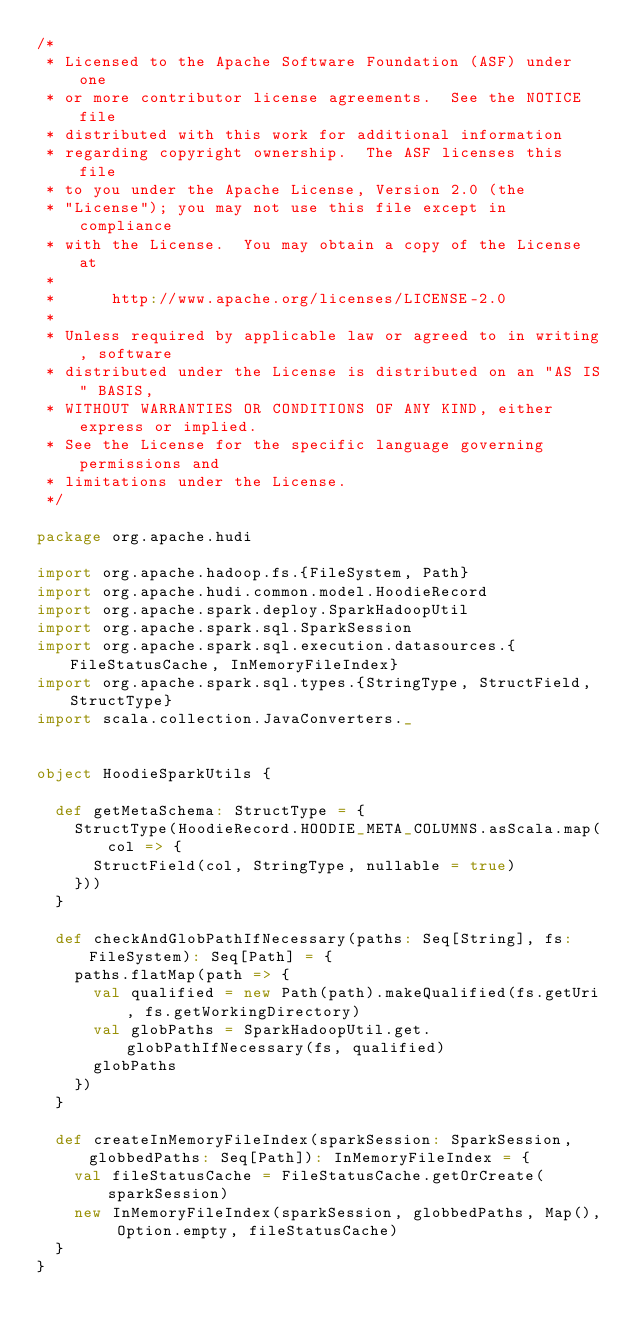Convert code to text. <code><loc_0><loc_0><loc_500><loc_500><_Scala_>/*
 * Licensed to the Apache Software Foundation (ASF) under one
 * or more contributor license agreements.  See the NOTICE file
 * distributed with this work for additional information
 * regarding copyright ownership.  The ASF licenses this file
 * to you under the Apache License, Version 2.0 (the
 * "License"); you may not use this file except in compliance
 * with the License.  You may obtain a copy of the License at
 *
 *      http://www.apache.org/licenses/LICENSE-2.0
 *
 * Unless required by applicable law or agreed to in writing, software
 * distributed under the License is distributed on an "AS IS" BASIS,
 * WITHOUT WARRANTIES OR CONDITIONS OF ANY KIND, either express or implied.
 * See the License for the specific language governing permissions and
 * limitations under the License.
 */

package org.apache.hudi

import org.apache.hadoop.fs.{FileSystem, Path}
import org.apache.hudi.common.model.HoodieRecord
import org.apache.spark.deploy.SparkHadoopUtil
import org.apache.spark.sql.SparkSession
import org.apache.spark.sql.execution.datasources.{FileStatusCache, InMemoryFileIndex}
import org.apache.spark.sql.types.{StringType, StructField, StructType}
import scala.collection.JavaConverters._


object HoodieSparkUtils {

  def getMetaSchema: StructType = {
    StructType(HoodieRecord.HOODIE_META_COLUMNS.asScala.map(col => {
      StructField(col, StringType, nullable = true)
    }))
  }

  def checkAndGlobPathIfNecessary(paths: Seq[String], fs: FileSystem): Seq[Path] = {
    paths.flatMap(path => {
      val qualified = new Path(path).makeQualified(fs.getUri, fs.getWorkingDirectory)
      val globPaths = SparkHadoopUtil.get.globPathIfNecessary(fs, qualified)
      globPaths
    })
  }

  def createInMemoryFileIndex(sparkSession: SparkSession, globbedPaths: Seq[Path]): InMemoryFileIndex = {
    val fileStatusCache = FileStatusCache.getOrCreate(sparkSession)
    new InMemoryFileIndex(sparkSession, globbedPaths, Map(), Option.empty, fileStatusCache)
  }
}
</code> 